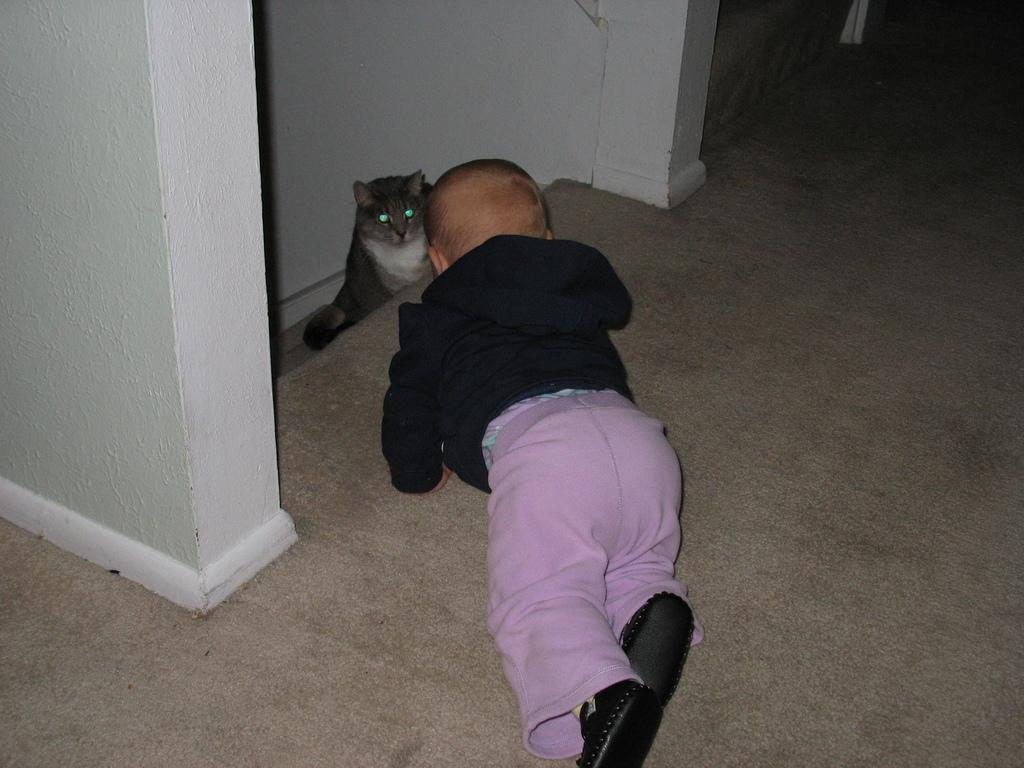What type of space is depicted in the image? The image is of a room. What can be found in the room? There is a baby and a cat sitting in the room. What is one of the boundaries of the room? There is a wall in the room. What is on the floor in the room? There is a mat at the bottom of the room. What month is it in the image? The image does not provide any information about the month, as it is a still image and not a video or a series of images. --- Facts: 1. There is a person sitting on a chair in the image. 2. The person is holding a book. 3. There is a table next to the chair. 4. There is a lamp on the table. 5. The background of the image is a bookshelf. Absurd Topics: ocean, bicycle, bird Conversation: What is the person in the image doing? The person is sitting on a chair in the image. What is the person holding in the image? The person is holding a book. What is located next to the chair? There is a table next to the chair. What is on the table? There is a lamp on the table. What can be seen in the background of the image? The background of the image is a bookshelf. Reasoning: Let's think step by step in order to produce the conversation. We start by identifying the main subject in the image, which is the person sitting on a chair. Then, we expand the conversation to include other items that are also visible, such as the book, table, lamp, and bookshelf. Each question is designed to elicit a specific detail about the image that is known from the provided facts. Absurd Question/Answer: Can you see any bicycles or birds in the image? No, there are no bicycles or birds present in the image. 